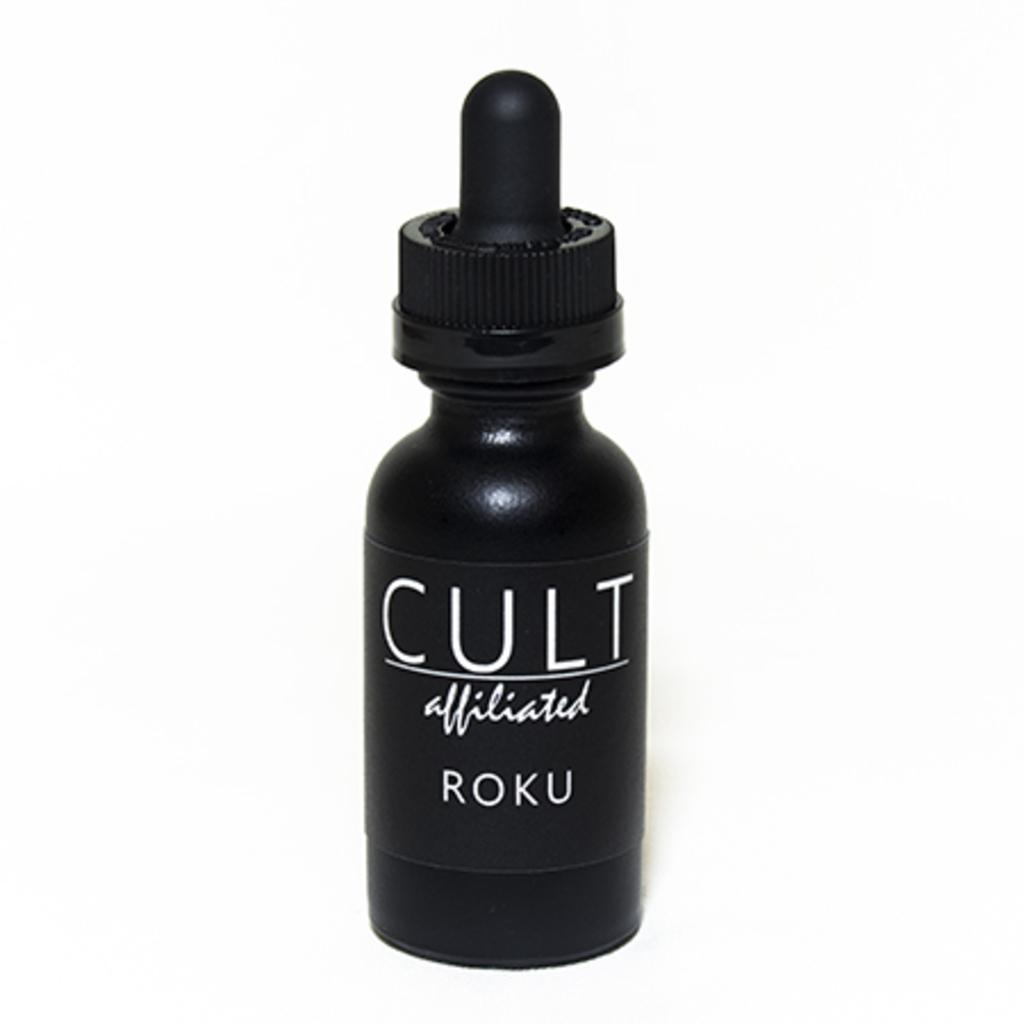Provide a one-sentence caption for the provided image. A black bottle hase white lettering of "cult affiliated roku.". 